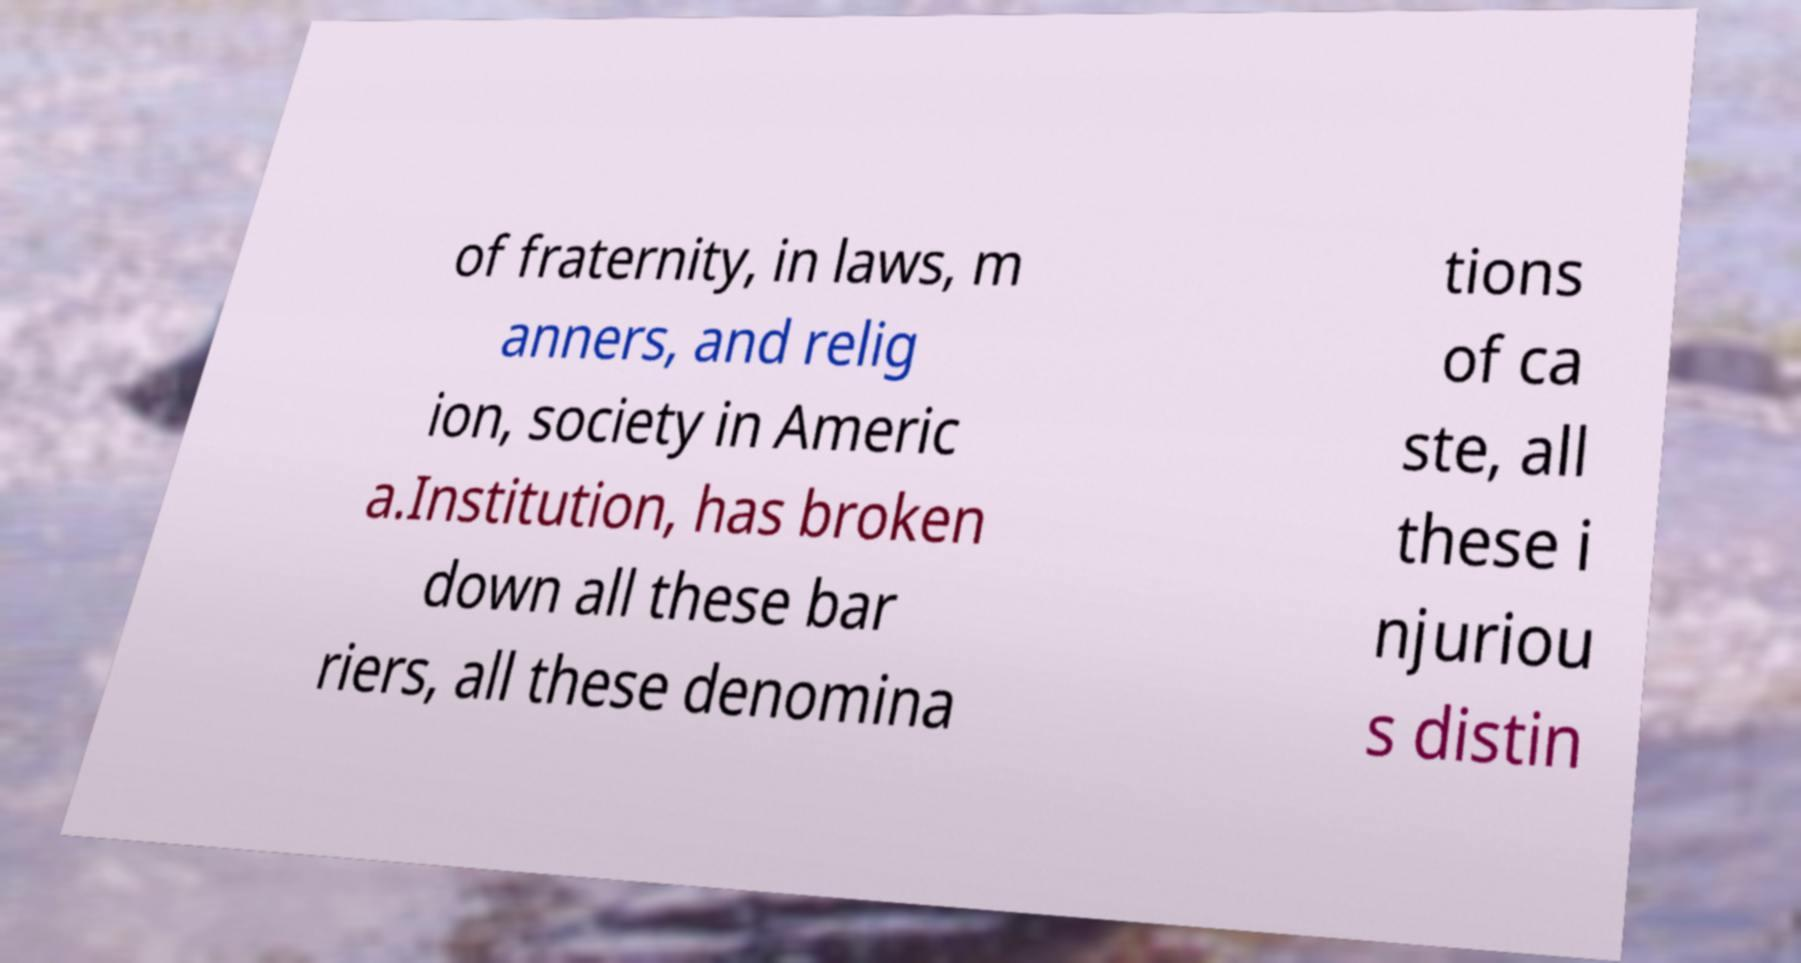There's text embedded in this image that I need extracted. Can you transcribe it verbatim? of fraternity, in laws, m anners, and relig ion, society in Americ a.Institution, has broken down all these bar riers, all these denomina tions of ca ste, all these i njuriou s distin 